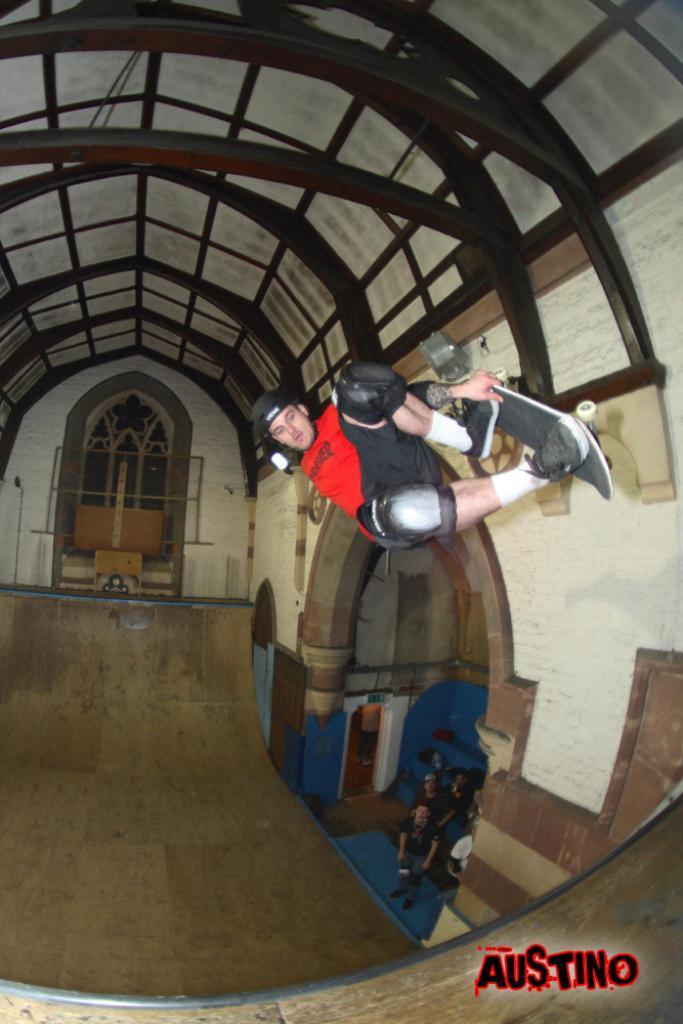Describe this image in one or two sentences. In this picture we can see the ground, here we can see a group of people and one person is on a skateboard and in the background we can see a wall, roof and some objects, in the bottom right we can see some text on it. 